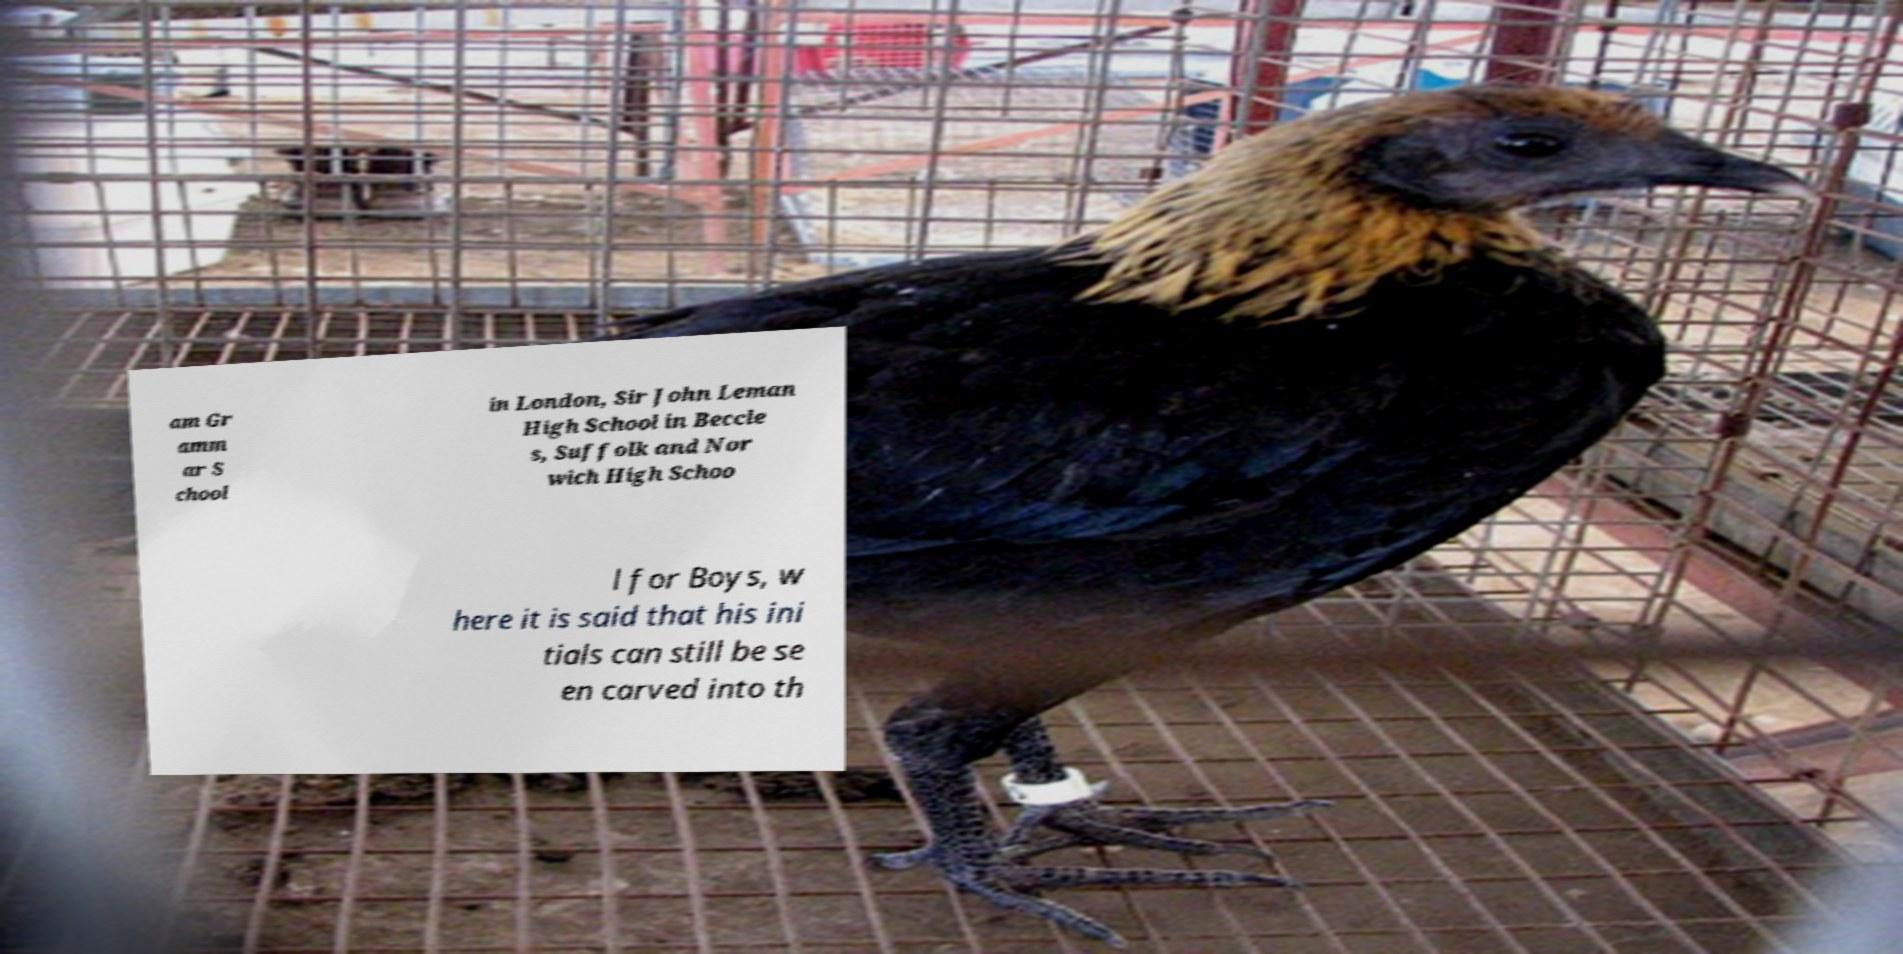There's text embedded in this image that I need extracted. Can you transcribe it verbatim? am Gr amm ar S chool in London, Sir John Leman High School in Beccle s, Suffolk and Nor wich High Schoo l for Boys, w here it is said that his ini tials can still be se en carved into th 